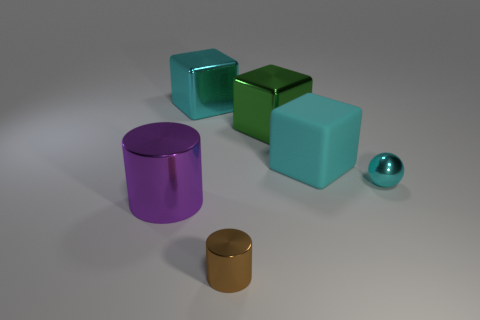Add 3 small brown things. How many objects exist? 9 Subtract all cylinders. How many objects are left? 4 Add 5 cubes. How many cubes exist? 8 Subtract 0 red cylinders. How many objects are left? 6 Subtract all big blocks. Subtract all big blue cylinders. How many objects are left? 3 Add 2 big green cubes. How many big green cubes are left? 3 